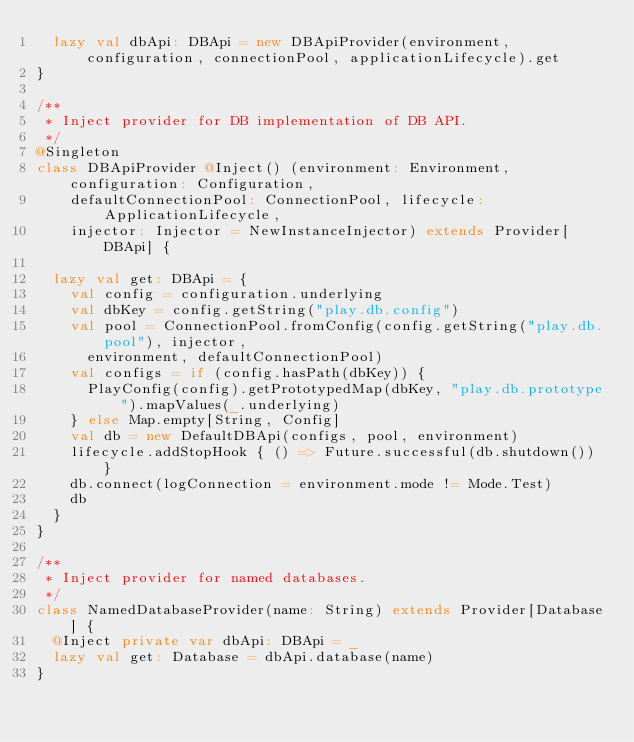Convert code to text. <code><loc_0><loc_0><loc_500><loc_500><_Scala_>  lazy val dbApi: DBApi = new DBApiProvider(environment, configuration, connectionPool, applicationLifecycle).get
}

/**
 * Inject provider for DB implementation of DB API.
 */
@Singleton
class DBApiProvider @Inject() (environment: Environment, configuration: Configuration,
    defaultConnectionPool: ConnectionPool, lifecycle: ApplicationLifecycle,
    injector: Injector = NewInstanceInjector) extends Provider[DBApi] {

  lazy val get: DBApi = {
    val config = configuration.underlying
    val dbKey = config.getString("play.db.config")
    val pool = ConnectionPool.fromConfig(config.getString("play.db.pool"), injector,
      environment, defaultConnectionPool)
    val configs = if (config.hasPath(dbKey)) {
      PlayConfig(config).getPrototypedMap(dbKey, "play.db.prototype").mapValues(_.underlying)
    } else Map.empty[String, Config]
    val db = new DefaultDBApi(configs, pool, environment)
    lifecycle.addStopHook { () => Future.successful(db.shutdown()) }
    db.connect(logConnection = environment.mode != Mode.Test)
    db
  }
}

/**
 * Inject provider for named databases.
 */
class NamedDatabaseProvider(name: String) extends Provider[Database] {
  @Inject private var dbApi: DBApi = _
  lazy val get: Database = dbApi.database(name)
}
</code> 